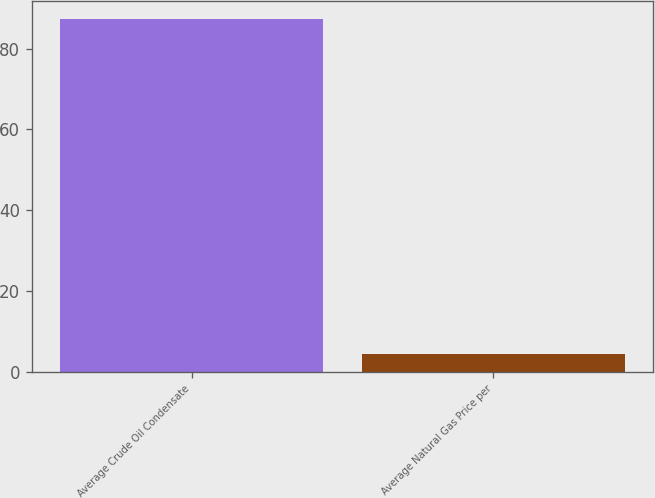Convert chart to OTSL. <chart><loc_0><loc_0><loc_500><loc_500><bar_chart><fcel>Average Crude Oil Condensate<fcel>Average Natural Gas Price per<nl><fcel>87.38<fcel>4.35<nl></chart> 